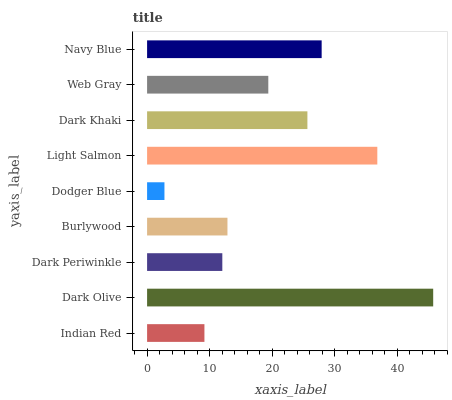Is Dodger Blue the minimum?
Answer yes or no. Yes. Is Dark Olive the maximum?
Answer yes or no. Yes. Is Dark Periwinkle the minimum?
Answer yes or no. No. Is Dark Periwinkle the maximum?
Answer yes or no. No. Is Dark Olive greater than Dark Periwinkle?
Answer yes or no. Yes. Is Dark Periwinkle less than Dark Olive?
Answer yes or no. Yes. Is Dark Periwinkle greater than Dark Olive?
Answer yes or no. No. Is Dark Olive less than Dark Periwinkle?
Answer yes or no. No. Is Web Gray the high median?
Answer yes or no. Yes. Is Web Gray the low median?
Answer yes or no. Yes. Is Indian Red the high median?
Answer yes or no. No. Is Navy Blue the low median?
Answer yes or no. No. 